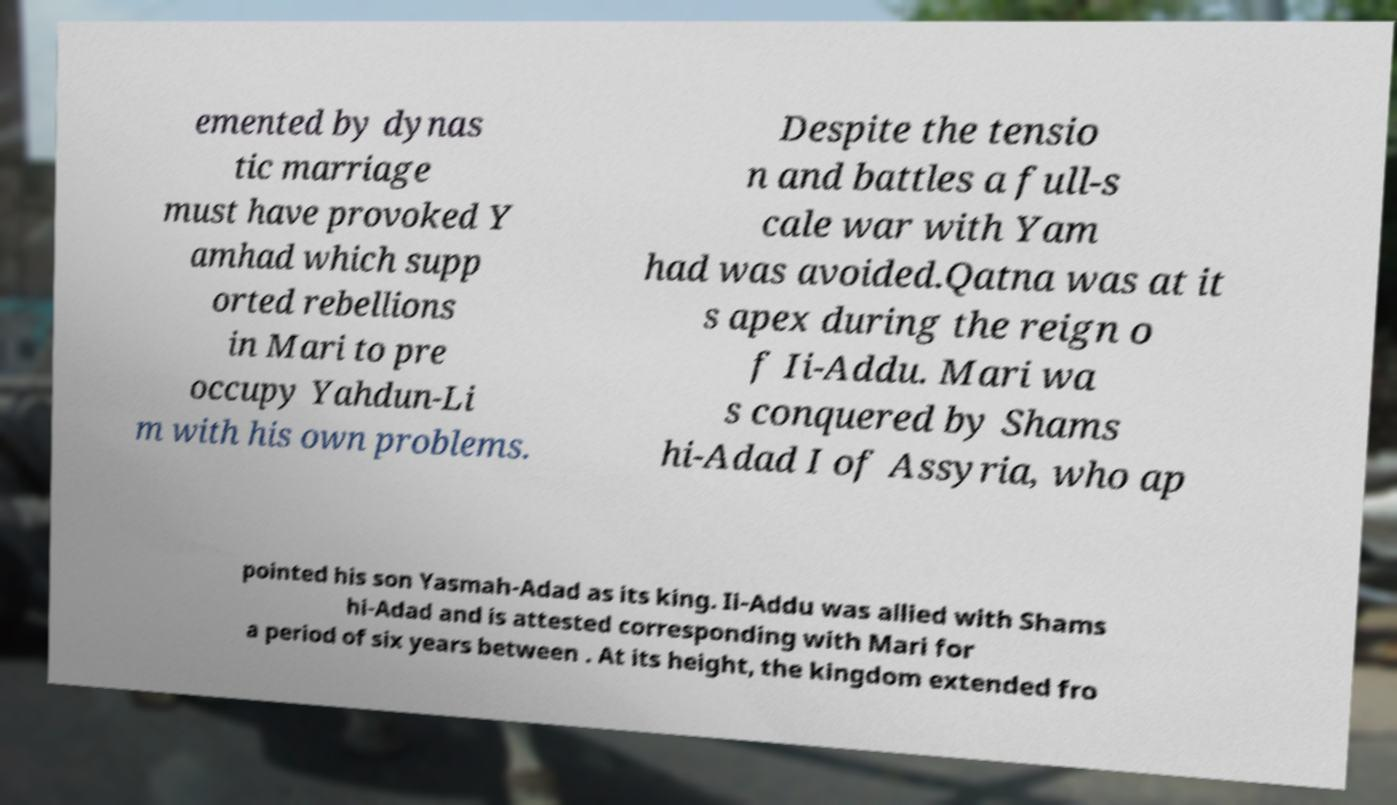There's text embedded in this image that I need extracted. Can you transcribe it verbatim? emented by dynas tic marriage must have provoked Y amhad which supp orted rebellions in Mari to pre occupy Yahdun-Li m with his own problems. Despite the tensio n and battles a full-s cale war with Yam had was avoided.Qatna was at it s apex during the reign o f Ii-Addu. Mari wa s conquered by Shams hi-Adad I of Assyria, who ap pointed his son Yasmah-Adad as its king. Ii-Addu was allied with Shams hi-Adad and is attested corresponding with Mari for a period of six years between . At its height, the kingdom extended fro 